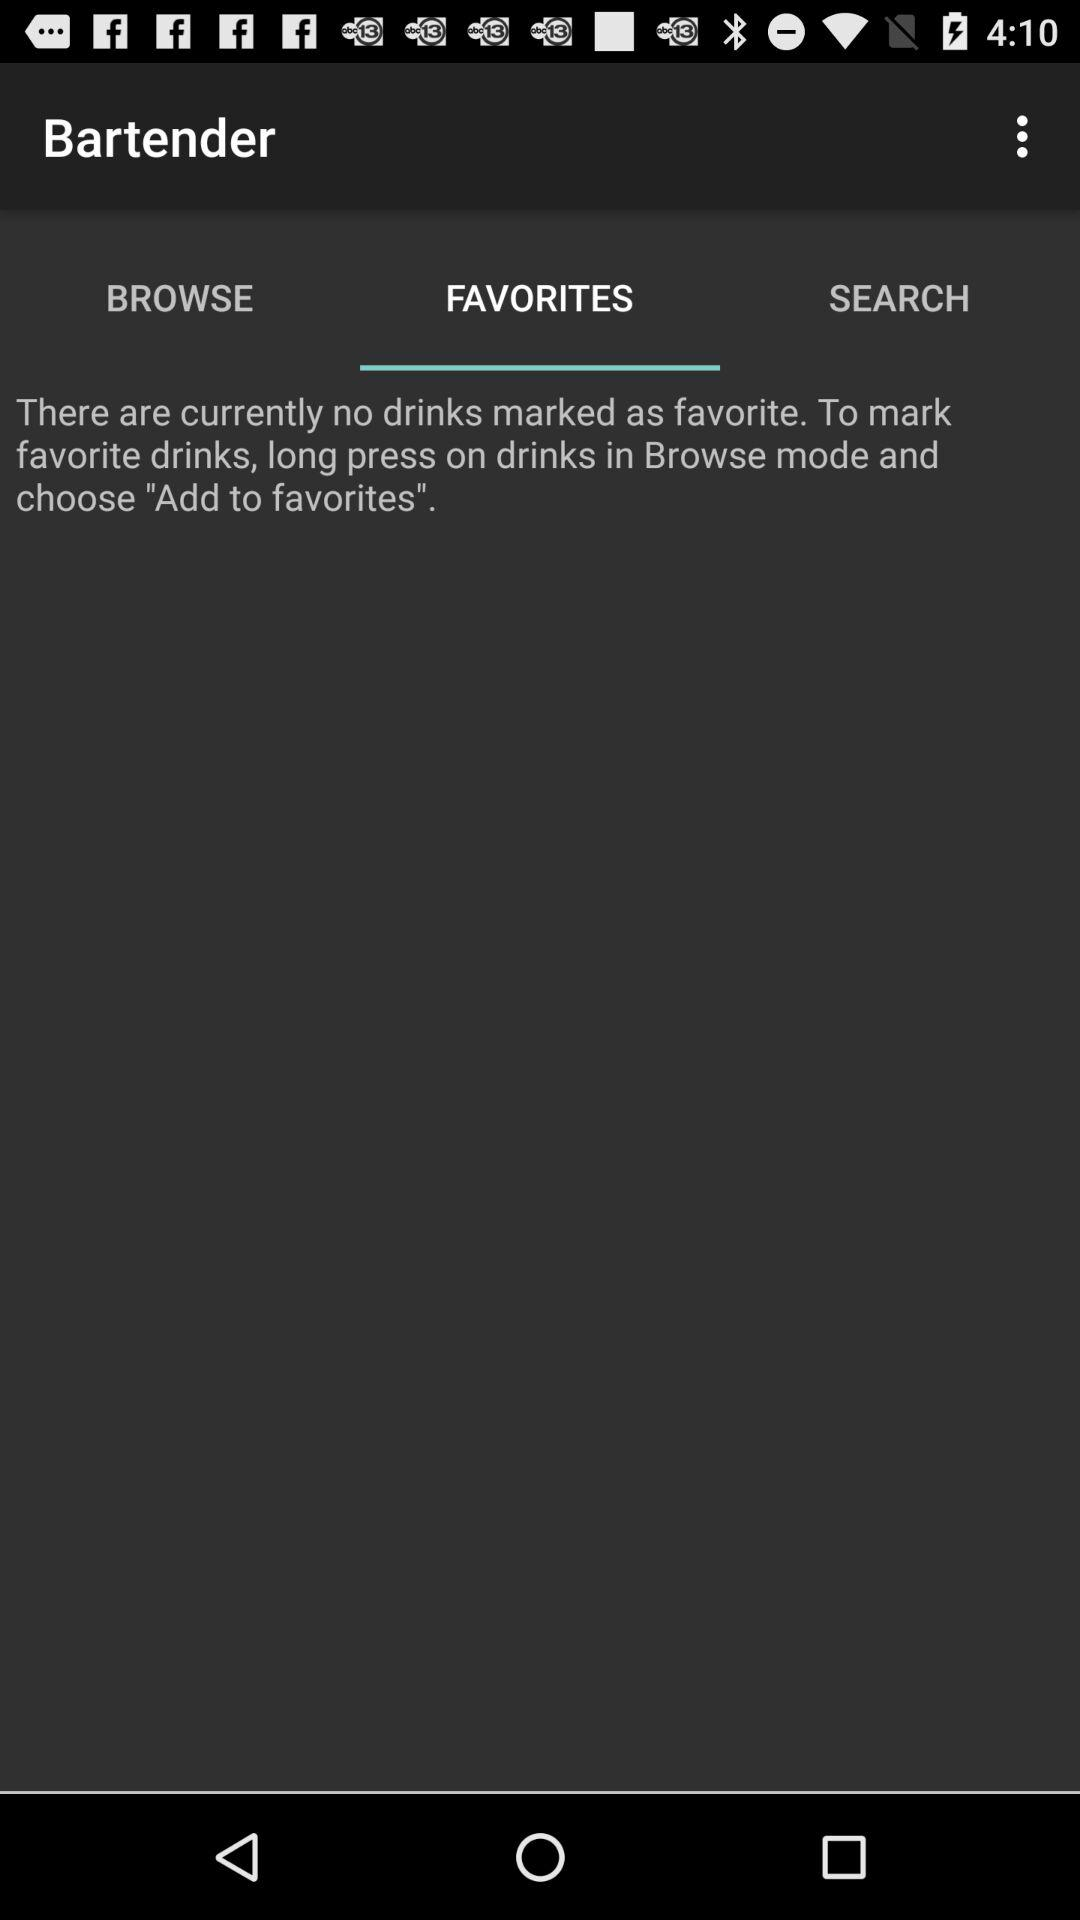How many drinks are marked as favorite?
Answer the question using a single word or phrase. 0 